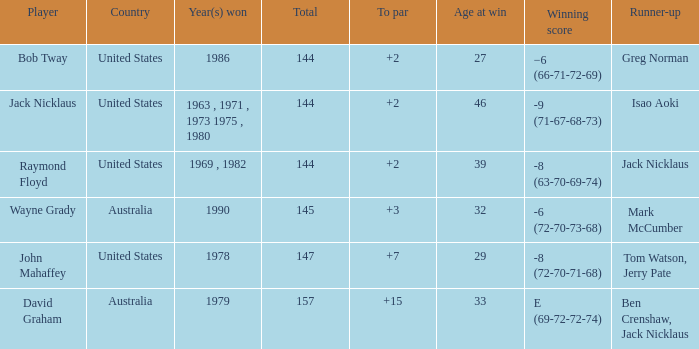How many strokes off par was the winner in 1978? 7.0. Write the full table. {'header': ['Player', 'Country', 'Year(s) won', 'Total', 'To par', 'Age at win', 'Winning score', 'Runner-up'], 'rows': [['Bob Tway', 'United States', '1986', '144', '+2', '27', '−6 (66-71-72-69)', 'Greg Norman'], ['Jack Nicklaus', 'United States', '1963 , 1971 , 1973 1975 , 1980', '144', '+2', '46', '-9 (71-67-68-73)', 'Isao Aoki'], ['Raymond Floyd', 'United States', '1969 , 1982', '144', '+2', '39', '-8 (63-70-69-74)', 'Jack Nicklaus'], ['Wayne Grady', 'Australia', '1990', '145', '+3', '32', '-6 (72-70-73-68)', 'Mark McCumber'], ['John Mahaffey', 'United States', '1978', '147', '+7', '29', '-8 (72-70-71-68)', 'Tom Watson, Jerry Pate'], ['David Graham', 'Australia', '1979', '157', '+15', '33', 'E (69-72-72-74)', 'Ben Crenshaw, Jack Nicklaus']]} 